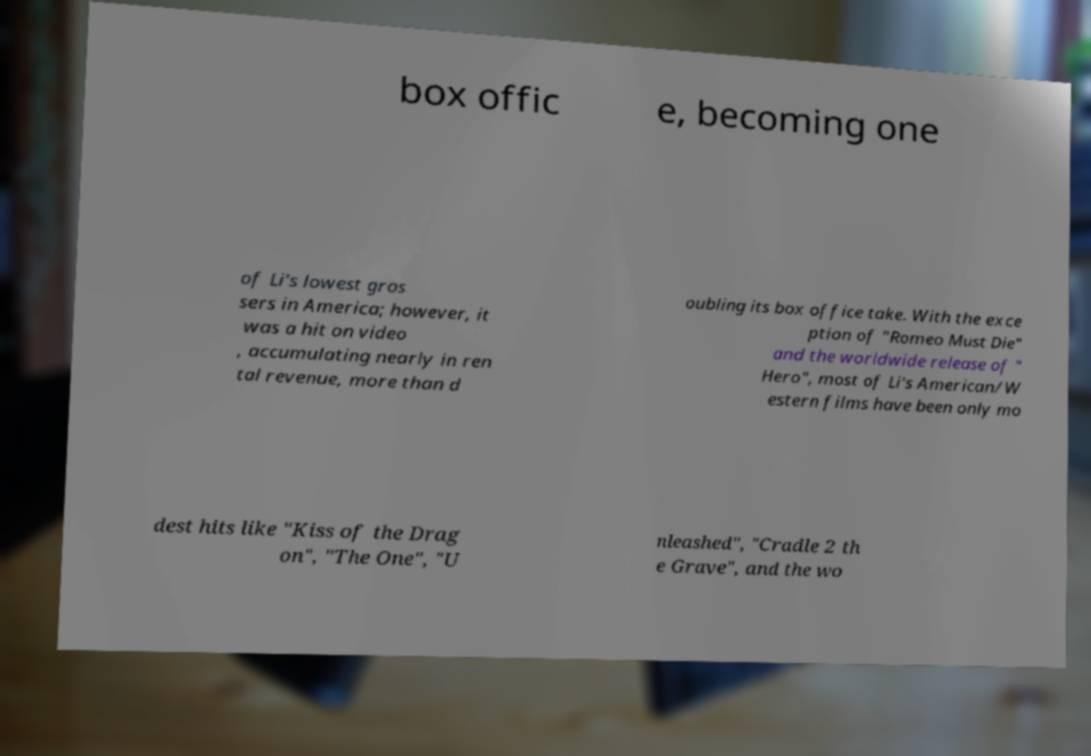For documentation purposes, I need the text within this image transcribed. Could you provide that? box offic e, becoming one of Li's lowest gros sers in America; however, it was a hit on video , accumulating nearly in ren tal revenue, more than d oubling its box office take. With the exce ption of "Romeo Must Die" and the worldwide release of " Hero", most of Li's American/W estern films have been only mo dest hits like "Kiss of the Drag on", "The One", "U nleashed", "Cradle 2 th e Grave", and the wo 